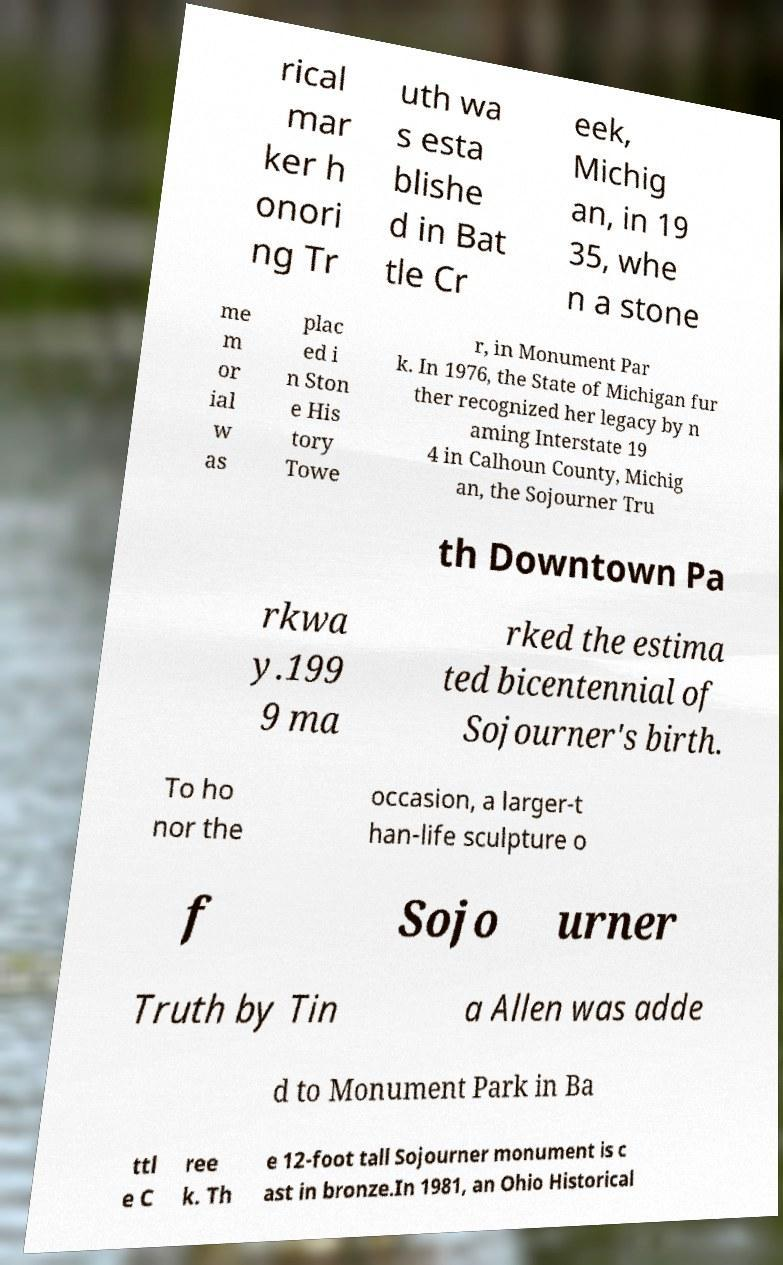Can you read and provide the text displayed in the image?This photo seems to have some interesting text. Can you extract and type it out for me? rical mar ker h onori ng Tr uth wa s esta blishe d in Bat tle Cr eek, Michig an, in 19 35, whe n a stone me m or ial w as plac ed i n Ston e His tory Towe r, in Monument Par k. In 1976, the State of Michigan fur ther recognized her legacy by n aming Interstate 19 4 in Calhoun County, Michig an, the Sojourner Tru th Downtown Pa rkwa y.199 9 ma rked the estima ted bicentennial of Sojourner's birth. To ho nor the occasion, a larger-t han-life sculpture o f Sojo urner Truth by Tin a Allen was adde d to Monument Park in Ba ttl e C ree k. Th e 12-foot tall Sojourner monument is c ast in bronze.In 1981, an Ohio Historical 